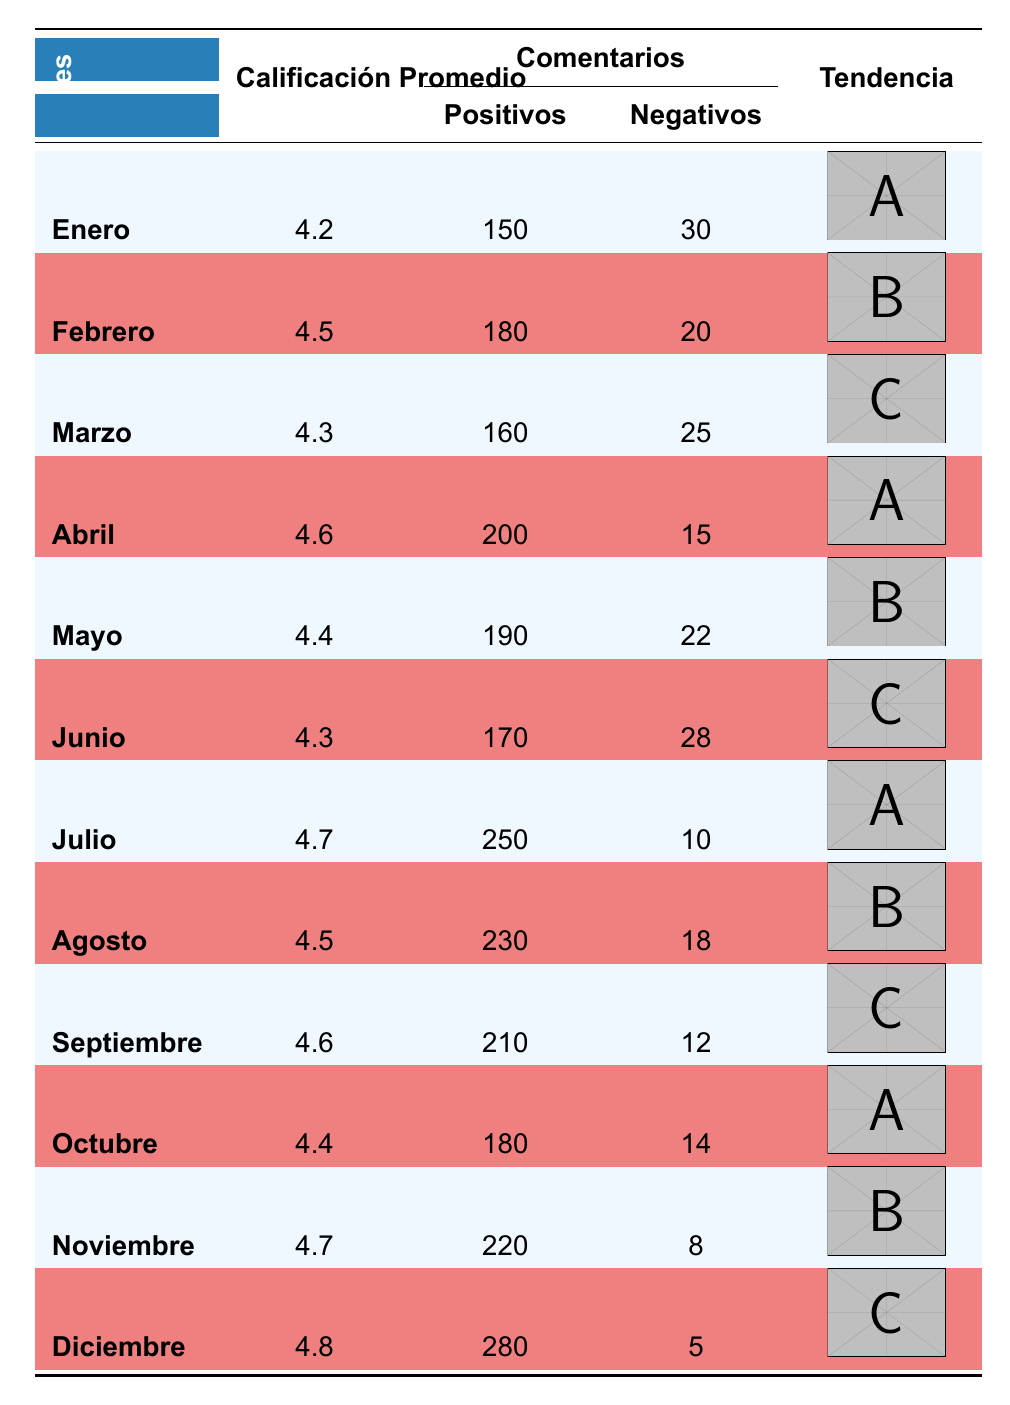What was the highest average rating recorded in 2023? The highest average rating can be found by looking at the "Calificación Promedio" column. In December, the average rating reached 4.8, which is higher than any other month.
Answer: 4.8 How many positive comments were recorded in March? In March, the table indicates 160 positive comments in the "Comentarios" section.
Answer: 160 What is the trend for negative comments over the first half of the year? To determine the trend in negative comments from January to June, sum the negative comments: January (30) + February (20) + March (25) + April (15) + May (22) + June (28) = 140. Observing the monthly data, the trend shows a decrease in negative comments from January (30) to April (15), but an increase again in May (22) and June (28). Therefore, the trend is fluctuating in the first half of the year.
Answer: Fluctuating Did the average rating increase every month from January to July? Checking the average rating column, we find: January (4.2), February (4.5), March (4.3), April (4.6), May (4.4), June (4.3), and July (4.7). Though February shows an increase, March to April shows stable, May decreases slightly, and June also decreases before increasing in July. Thus, the average rating did not increase every month.
Answer: No What is the difference in positive comments between May and December? The positive comments in May are 190 and in December, they are 280. To find the difference, we calculate 280 - 190 = 90. Thus, there are 90 more positive comments in December compared to May.
Answer: 90 How many months had an average rating above 4.5? By reviewing the average rating column, we find the months with ratings above 4.5 are February (4.5), April (4.6), July (4.7), August (4.5), September (4.6), November (4.7), and December (4.8). Counting these gives us a total of 7 months with ratings above 4.5.
Answer: 7 What was the maximum number of negative comments in a single month? The negative comments column shows the highest value in January with 30 comments. This is the maximum recorded compared to other months.
Answer: 30 What is the average number of positive comments from July to December? To find the average, we sum the positive comments from July (250) to December (280): 250 + 230 + 210 + 180 + 220 + 280 = 1370. There are 6 months in this period, so we calculate the average as 1370 / 6 = approximately 228.33, typically rounded to 228 for reporting.
Answer: 228 